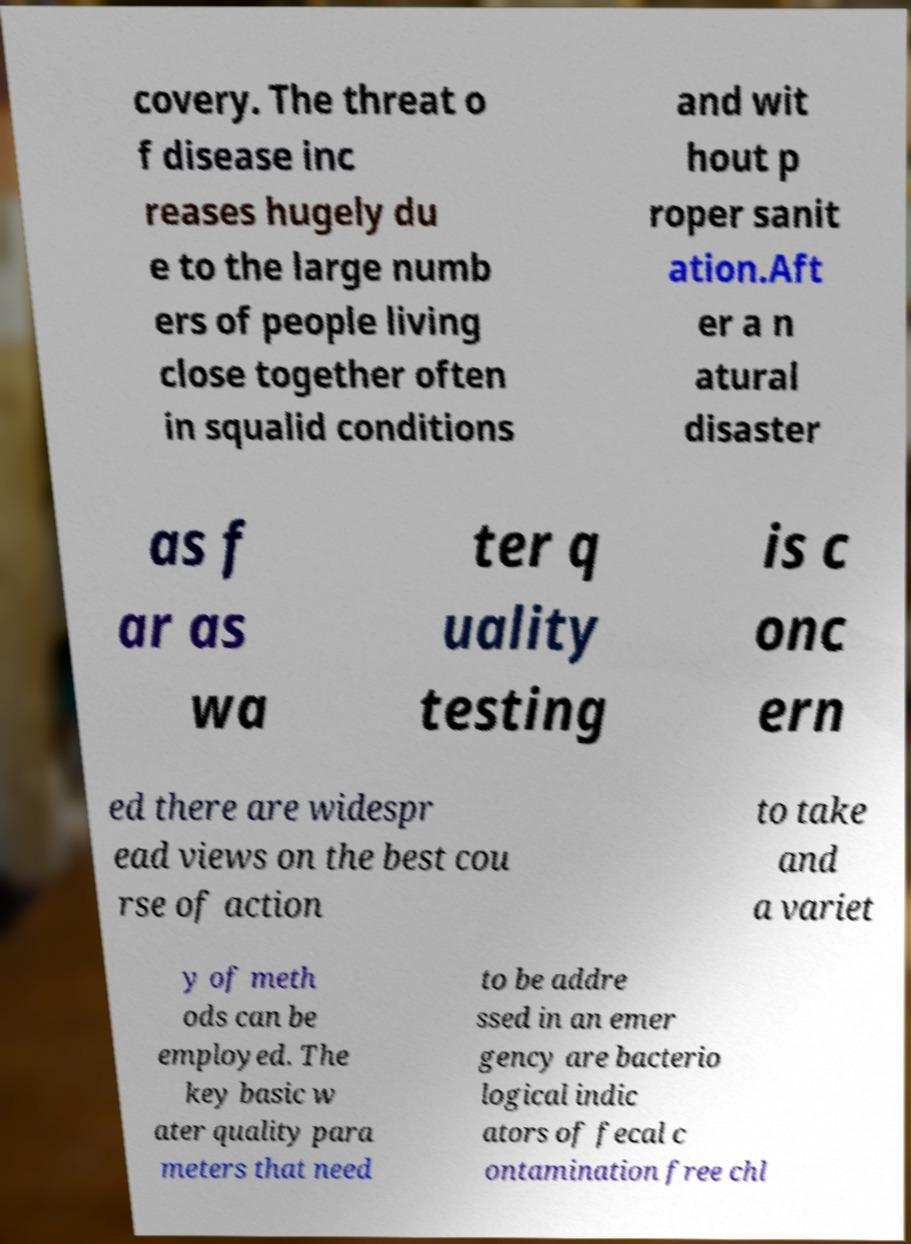For documentation purposes, I need the text within this image transcribed. Could you provide that? covery. The threat o f disease inc reases hugely du e to the large numb ers of people living close together often in squalid conditions and wit hout p roper sanit ation.Aft er a n atural disaster as f ar as wa ter q uality testing is c onc ern ed there are widespr ead views on the best cou rse of action to take and a variet y of meth ods can be employed. The key basic w ater quality para meters that need to be addre ssed in an emer gency are bacterio logical indic ators of fecal c ontamination free chl 